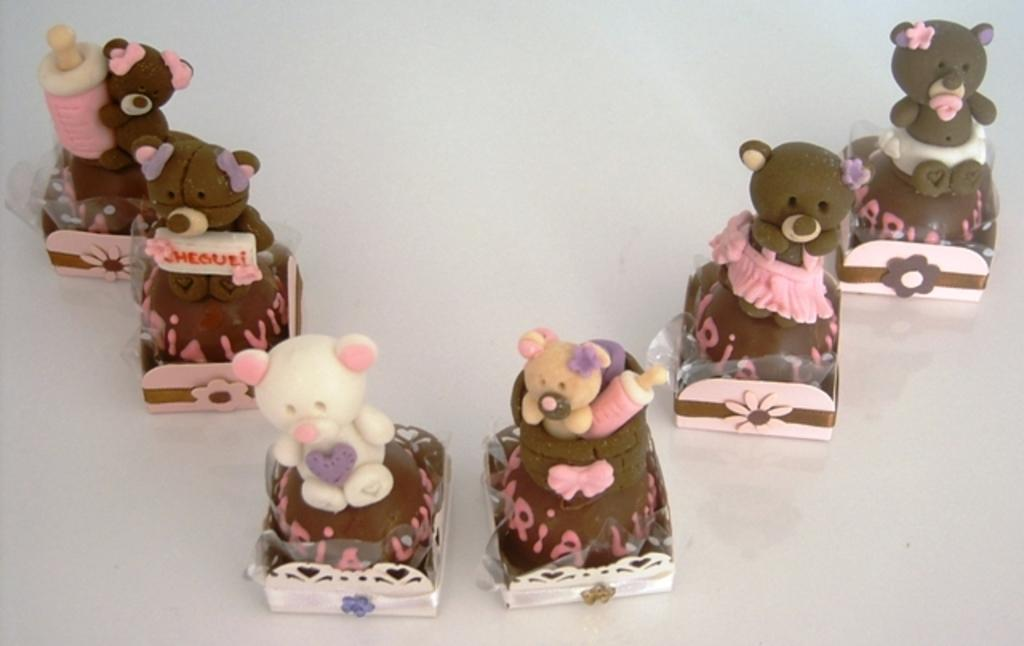What type of food is featured in the image? There are many cupcakes in the image. What is the cupcakes placed on? The cupcakes are placed on a white object. Are there any other objects or characters in the image? Yes, there are teddy bears and bottles in the image. What can be seen on the cupcakes? The cupcakes have text on them. What type of language do the planes in the image speak? There are no planes present in the image; it features cupcakes, teddy bears, and bottles. 